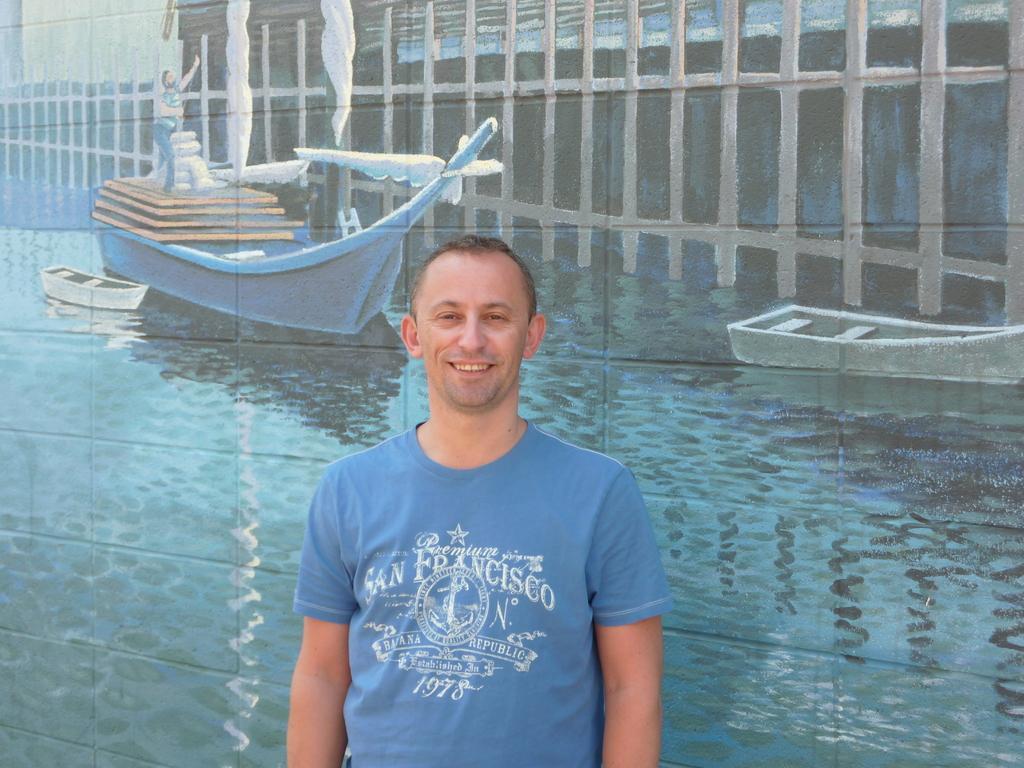Describe this image in one or two sentences. In the image we can see a man wearing blue color T-shirt and he is smiling, this is a painting. 